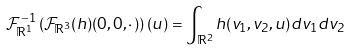<formula> <loc_0><loc_0><loc_500><loc_500>\mathcal { F } ^ { - 1 } _ { \mathbb { R } ^ { 1 } } \left ( \mathcal { F } _ { \mathbb { R } ^ { 3 } } ( h ) ( 0 , 0 , \cdot \, ) \right ) ( u ) = \int _ { { \mathbb { R } } ^ { 2 } } h ( v _ { 1 } , v _ { 2 } , u ) d v _ { 1 } d v _ { 2 } \,</formula> 